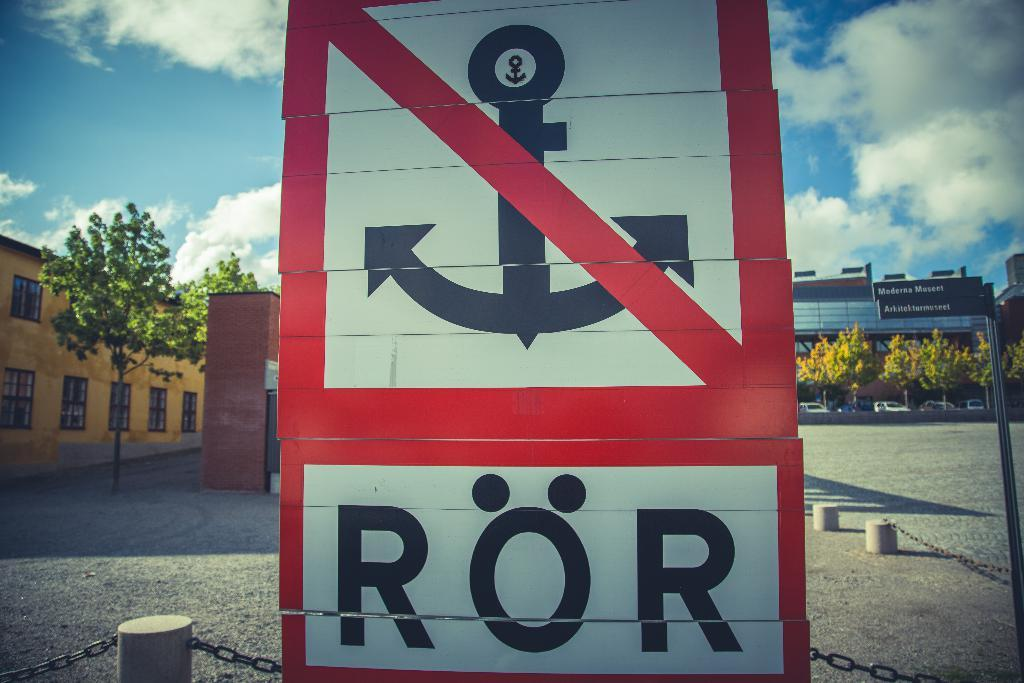<image>
Present a compact description of the photo's key features. A sign with the word "RÖR" at the bottom and an anchor above it that is crossed out in red. 